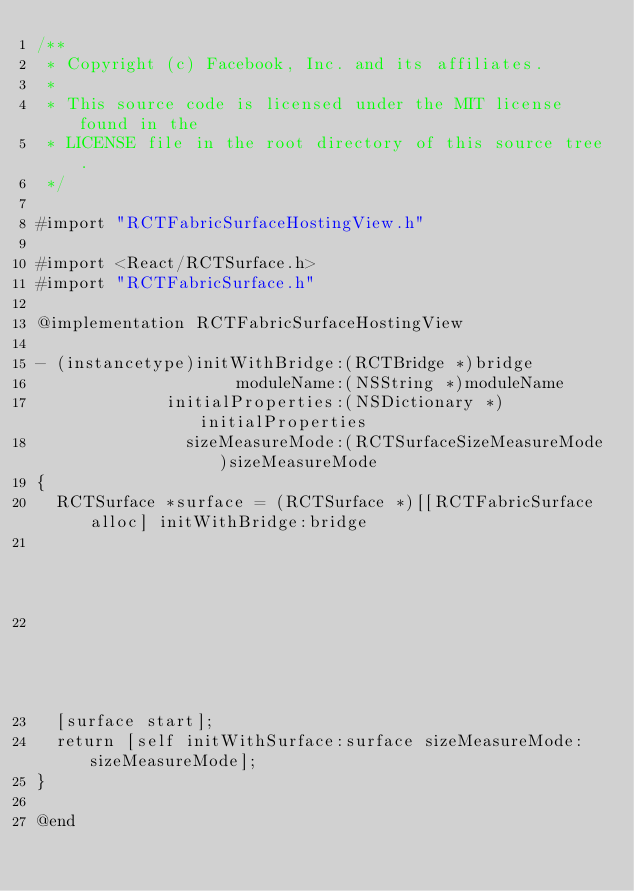Convert code to text. <code><loc_0><loc_0><loc_500><loc_500><_ObjectiveC_>/**
 * Copyright (c) Facebook, Inc. and its affiliates.
 *
 * This source code is licensed under the MIT license found in the
 * LICENSE file in the root directory of this source tree.
 */

#import "RCTFabricSurfaceHostingView.h"

#import <React/RCTSurface.h>
#import "RCTFabricSurface.h"

@implementation RCTFabricSurfaceHostingView

- (instancetype)initWithBridge:(RCTBridge *)bridge
                    moduleName:(NSString *)moduleName
             initialProperties:(NSDictionary *)initialProperties
               sizeMeasureMode:(RCTSurfaceSizeMeasureMode)sizeMeasureMode
{
  RCTSurface *surface = (RCTSurface *)[[RCTFabricSurface alloc] initWithBridge:bridge
                                                                    moduleName:moduleName
                                                             initialProperties:initialProperties];
  [surface start];
  return [self initWithSurface:surface sizeMeasureMode:sizeMeasureMode];
}

@end
</code> 